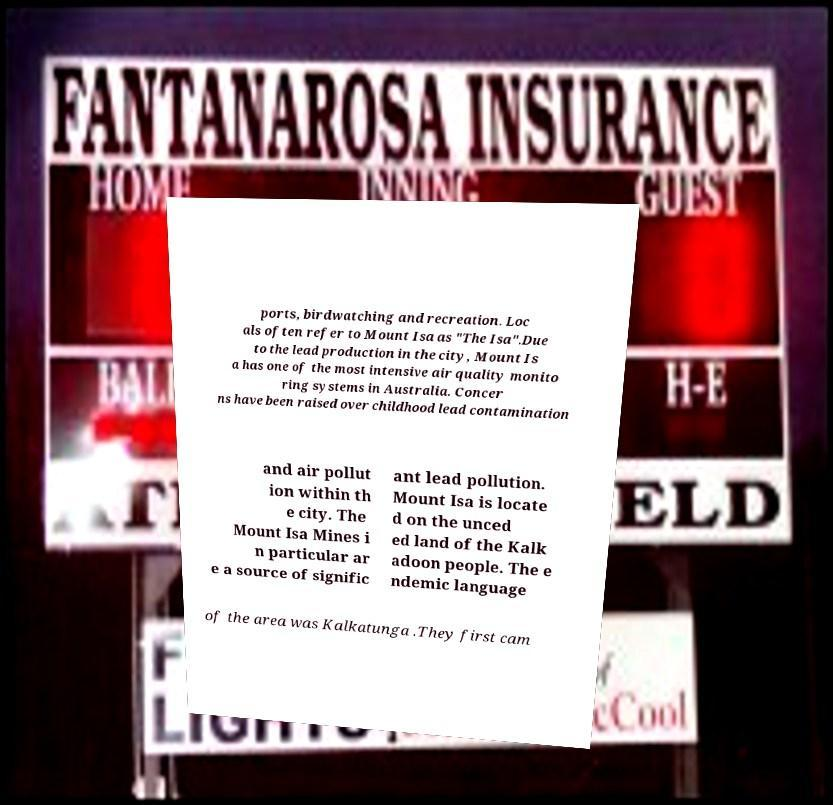For documentation purposes, I need the text within this image transcribed. Could you provide that? ports, birdwatching and recreation. Loc als often refer to Mount Isa as "The Isa".Due to the lead production in the city, Mount Is a has one of the most intensive air quality monito ring systems in Australia. Concer ns have been raised over childhood lead contamination and air pollut ion within th e city. The Mount Isa Mines i n particular ar e a source of signific ant lead pollution. Mount Isa is locate d on the unced ed land of the Kalk adoon people. The e ndemic language of the area was Kalkatunga .They first cam 